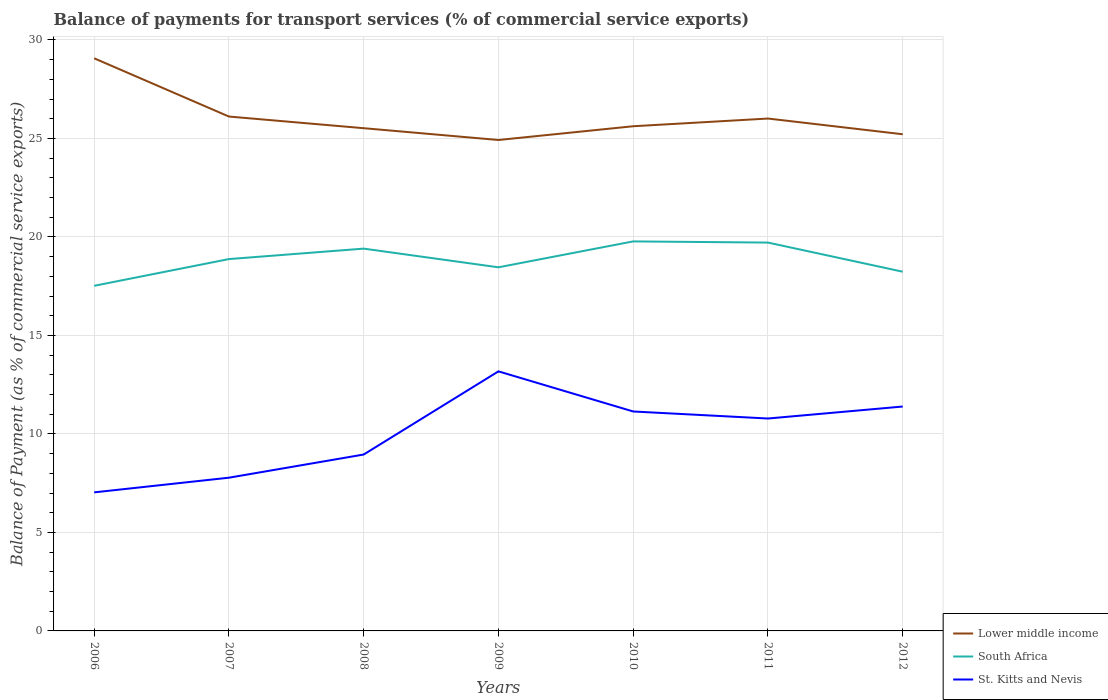Does the line corresponding to St. Kitts and Nevis intersect with the line corresponding to South Africa?
Ensure brevity in your answer.  No. Is the number of lines equal to the number of legend labels?
Ensure brevity in your answer.  Yes. Across all years, what is the maximum balance of payments for transport services in South Africa?
Offer a terse response. 17.52. What is the total balance of payments for transport services in Lower middle income in the graph?
Your answer should be compact. 4.15. What is the difference between the highest and the second highest balance of payments for transport services in South Africa?
Your answer should be compact. 2.25. How many years are there in the graph?
Your answer should be very brief. 7. Where does the legend appear in the graph?
Keep it short and to the point. Bottom right. How are the legend labels stacked?
Keep it short and to the point. Vertical. What is the title of the graph?
Give a very brief answer. Balance of payments for transport services (% of commercial service exports). What is the label or title of the X-axis?
Provide a short and direct response. Years. What is the label or title of the Y-axis?
Ensure brevity in your answer.  Balance of Payment (as % of commercial service exports). What is the Balance of Payment (as % of commercial service exports) in Lower middle income in 2006?
Keep it short and to the point. 29.07. What is the Balance of Payment (as % of commercial service exports) of South Africa in 2006?
Your answer should be very brief. 17.52. What is the Balance of Payment (as % of commercial service exports) in St. Kitts and Nevis in 2006?
Provide a short and direct response. 7.03. What is the Balance of Payment (as % of commercial service exports) of Lower middle income in 2007?
Ensure brevity in your answer.  26.11. What is the Balance of Payment (as % of commercial service exports) in South Africa in 2007?
Your answer should be compact. 18.88. What is the Balance of Payment (as % of commercial service exports) of St. Kitts and Nevis in 2007?
Your answer should be very brief. 7.78. What is the Balance of Payment (as % of commercial service exports) of Lower middle income in 2008?
Offer a very short reply. 25.52. What is the Balance of Payment (as % of commercial service exports) in South Africa in 2008?
Offer a terse response. 19.41. What is the Balance of Payment (as % of commercial service exports) of St. Kitts and Nevis in 2008?
Provide a short and direct response. 8.95. What is the Balance of Payment (as % of commercial service exports) of Lower middle income in 2009?
Provide a short and direct response. 24.92. What is the Balance of Payment (as % of commercial service exports) in South Africa in 2009?
Your answer should be compact. 18.46. What is the Balance of Payment (as % of commercial service exports) of St. Kitts and Nevis in 2009?
Ensure brevity in your answer.  13.18. What is the Balance of Payment (as % of commercial service exports) in Lower middle income in 2010?
Offer a very short reply. 25.62. What is the Balance of Payment (as % of commercial service exports) in South Africa in 2010?
Ensure brevity in your answer.  19.77. What is the Balance of Payment (as % of commercial service exports) in St. Kitts and Nevis in 2010?
Your answer should be compact. 11.14. What is the Balance of Payment (as % of commercial service exports) in Lower middle income in 2011?
Your response must be concise. 26.01. What is the Balance of Payment (as % of commercial service exports) in South Africa in 2011?
Keep it short and to the point. 19.71. What is the Balance of Payment (as % of commercial service exports) of St. Kitts and Nevis in 2011?
Offer a terse response. 10.78. What is the Balance of Payment (as % of commercial service exports) of Lower middle income in 2012?
Ensure brevity in your answer.  25.21. What is the Balance of Payment (as % of commercial service exports) of South Africa in 2012?
Give a very brief answer. 18.23. What is the Balance of Payment (as % of commercial service exports) in St. Kitts and Nevis in 2012?
Offer a very short reply. 11.39. Across all years, what is the maximum Balance of Payment (as % of commercial service exports) in Lower middle income?
Make the answer very short. 29.07. Across all years, what is the maximum Balance of Payment (as % of commercial service exports) in South Africa?
Provide a succinct answer. 19.77. Across all years, what is the maximum Balance of Payment (as % of commercial service exports) of St. Kitts and Nevis?
Give a very brief answer. 13.18. Across all years, what is the minimum Balance of Payment (as % of commercial service exports) in Lower middle income?
Offer a terse response. 24.92. Across all years, what is the minimum Balance of Payment (as % of commercial service exports) of South Africa?
Give a very brief answer. 17.52. Across all years, what is the minimum Balance of Payment (as % of commercial service exports) in St. Kitts and Nevis?
Provide a succinct answer. 7.03. What is the total Balance of Payment (as % of commercial service exports) of Lower middle income in the graph?
Provide a short and direct response. 182.46. What is the total Balance of Payment (as % of commercial service exports) of South Africa in the graph?
Your answer should be very brief. 131.98. What is the total Balance of Payment (as % of commercial service exports) in St. Kitts and Nevis in the graph?
Give a very brief answer. 70.26. What is the difference between the Balance of Payment (as % of commercial service exports) of Lower middle income in 2006 and that in 2007?
Your answer should be very brief. 2.96. What is the difference between the Balance of Payment (as % of commercial service exports) in South Africa in 2006 and that in 2007?
Your response must be concise. -1.36. What is the difference between the Balance of Payment (as % of commercial service exports) in St. Kitts and Nevis in 2006 and that in 2007?
Your response must be concise. -0.74. What is the difference between the Balance of Payment (as % of commercial service exports) of Lower middle income in 2006 and that in 2008?
Offer a very short reply. 3.55. What is the difference between the Balance of Payment (as % of commercial service exports) in South Africa in 2006 and that in 2008?
Offer a very short reply. -1.89. What is the difference between the Balance of Payment (as % of commercial service exports) in St. Kitts and Nevis in 2006 and that in 2008?
Your response must be concise. -1.92. What is the difference between the Balance of Payment (as % of commercial service exports) in Lower middle income in 2006 and that in 2009?
Your answer should be very brief. 4.15. What is the difference between the Balance of Payment (as % of commercial service exports) in South Africa in 2006 and that in 2009?
Your response must be concise. -0.94. What is the difference between the Balance of Payment (as % of commercial service exports) in St. Kitts and Nevis in 2006 and that in 2009?
Your answer should be compact. -6.14. What is the difference between the Balance of Payment (as % of commercial service exports) of Lower middle income in 2006 and that in 2010?
Keep it short and to the point. 3.45. What is the difference between the Balance of Payment (as % of commercial service exports) of South Africa in 2006 and that in 2010?
Your answer should be compact. -2.25. What is the difference between the Balance of Payment (as % of commercial service exports) of St. Kitts and Nevis in 2006 and that in 2010?
Offer a very short reply. -4.11. What is the difference between the Balance of Payment (as % of commercial service exports) of Lower middle income in 2006 and that in 2011?
Your answer should be compact. 3.06. What is the difference between the Balance of Payment (as % of commercial service exports) in South Africa in 2006 and that in 2011?
Your response must be concise. -2.19. What is the difference between the Balance of Payment (as % of commercial service exports) in St. Kitts and Nevis in 2006 and that in 2011?
Offer a terse response. -3.75. What is the difference between the Balance of Payment (as % of commercial service exports) of Lower middle income in 2006 and that in 2012?
Provide a succinct answer. 3.86. What is the difference between the Balance of Payment (as % of commercial service exports) of South Africa in 2006 and that in 2012?
Give a very brief answer. -0.72. What is the difference between the Balance of Payment (as % of commercial service exports) of St. Kitts and Nevis in 2006 and that in 2012?
Offer a very short reply. -4.36. What is the difference between the Balance of Payment (as % of commercial service exports) of Lower middle income in 2007 and that in 2008?
Offer a very short reply. 0.59. What is the difference between the Balance of Payment (as % of commercial service exports) in South Africa in 2007 and that in 2008?
Your answer should be very brief. -0.53. What is the difference between the Balance of Payment (as % of commercial service exports) of St. Kitts and Nevis in 2007 and that in 2008?
Ensure brevity in your answer.  -1.18. What is the difference between the Balance of Payment (as % of commercial service exports) of Lower middle income in 2007 and that in 2009?
Give a very brief answer. 1.19. What is the difference between the Balance of Payment (as % of commercial service exports) in South Africa in 2007 and that in 2009?
Provide a short and direct response. 0.42. What is the difference between the Balance of Payment (as % of commercial service exports) in St. Kitts and Nevis in 2007 and that in 2009?
Keep it short and to the point. -5.4. What is the difference between the Balance of Payment (as % of commercial service exports) in Lower middle income in 2007 and that in 2010?
Provide a short and direct response. 0.49. What is the difference between the Balance of Payment (as % of commercial service exports) of South Africa in 2007 and that in 2010?
Your response must be concise. -0.9. What is the difference between the Balance of Payment (as % of commercial service exports) of St. Kitts and Nevis in 2007 and that in 2010?
Make the answer very short. -3.36. What is the difference between the Balance of Payment (as % of commercial service exports) in Lower middle income in 2007 and that in 2011?
Keep it short and to the point. 0.1. What is the difference between the Balance of Payment (as % of commercial service exports) in South Africa in 2007 and that in 2011?
Give a very brief answer. -0.84. What is the difference between the Balance of Payment (as % of commercial service exports) in St. Kitts and Nevis in 2007 and that in 2011?
Keep it short and to the point. -3. What is the difference between the Balance of Payment (as % of commercial service exports) of Lower middle income in 2007 and that in 2012?
Offer a very short reply. 0.9. What is the difference between the Balance of Payment (as % of commercial service exports) of South Africa in 2007 and that in 2012?
Make the answer very short. 0.64. What is the difference between the Balance of Payment (as % of commercial service exports) in St. Kitts and Nevis in 2007 and that in 2012?
Keep it short and to the point. -3.61. What is the difference between the Balance of Payment (as % of commercial service exports) of Lower middle income in 2008 and that in 2009?
Provide a short and direct response. 0.6. What is the difference between the Balance of Payment (as % of commercial service exports) of South Africa in 2008 and that in 2009?
Provide a short and direct response. 0.95. What is the difference between the Balance of Payment (as % of commercial service exports) of St. Kitts and Nevis in 2008 and that in 2009?
Provide a succinct answer. -4.22. What is the difference between the Balance of Payment (as % of commercial service exports) in Lower middle income in 2008 and that in 2010?
Offer a terse response. -0.1. What is the difference between the Balance of Payment (as % of commercial service exports) in South Africa in 2008 and that in 2010?
Provide a succinct answer. -0.37. What is the difference between the Balance of Payment (as % of commercial service exports) in St. Kitts and Nevis in 2008 and that in 2010?
Offer a terse response. -2.19. What is the difference between the Balance of Payment (as % of commercial service exports) in Lower middle income in 2008 and that in 2011?
Offer a terse response. -0.49. What is the difference between the Balance of Payment (as % of commercial service exports) of South Africa in 2008 and that in 2011?
Offer a terse response. -0.31. What is the difference between the Balance of Payment (as % of commercial service exports) of St. Kitts and Nevis in 2008 and that in 2011?
Provide a short and direct response. -1.83. What is the difference between the Balance of Payment (as % of commercial service exports) in Lower middle income in 2008 and that in 2012?
Give a very brief answer. 0.31. What is the difference between the Balance of Payment (as % of commercial service exports) in South Africa in 2008 and that in 2012?
Your response must be concise. 1.17. What is the difference between the Balance of Payment (as % of commercial service exports) in St. Kitts and Nevis in 2008 and that in 2012?
Provide a succinct answer. -2.44. What is the difference between the Balance of Payment (as % of commercial service exports) in Lower middle income in 2009 and that in 2010?
Provide a succinct answer. -0.7. What is the difference between the Balance of Payment (as % of commercial service exports) in South Africa in 2009 and that in 2010?
Provide a short and direct response. -1.31. What is the difference between the Balance of Payment (as % of commercial service exports) in St. Kitts and Nevis in 2009 and that in 2010?
Ensure brevity in your answer.  2.04. What is the difference between the Balance of Payment (as % of commercial service exports) in Lower middle income in 2009 and that in 2011?
Provide a succinct answer. -1.09. What is the difference between the Balance of Payment (as % of commercial service exports) in South Africa in 2009 and that in 2011?
Make the answer very short. -1.25. What is the difference between the Balance of Payment (as % of commercial service exports) of St. Kitts and Nevis in 2009 and that in 2011?
Keep it short and to the point. 2.39. What is the difference between the Balance of Payment (as % of commercial service exports) in Lower middle income in 2009 and that in 2012?
Make the answer very short. -0.29. What is the difference between the Balance of Payment (as % of commercial service exports) of South Africa in 2009 and that in 2012?
Your answer should be very brief. 0.22. What is the difference between the Balance of Payment (as % of commercial service exports) in St. Kitts and Nevis in 2009 and that in 2012?
Your answer should be compact. 1.79. What is the difference between the Balance of Payment (as % of commercial service exports) of Lower middle income in 2010 and that in 2011?
Give a very brief answer. -0.39. What is the difference between the Balance of Payment (as % of commercial service exports) of South Africa in 2010 and that in 2011?
Keep it short and to the point. 0.06. What is the difference between the Balance of Payment (as % of commercial service exports) of St. Kitts and Nevis in 2010 and that in 2011?
Provide a succinct answer. 0.36. What is the difference between the Balance of Payment (as % of commercial service exports) of Lower middle income in 2010 and that in 2012?
Offer a terse response. 0.41. What is the difference between the Balance of Payment (as % of commercial service exports) in South Africa in 2010 and that in 2012?
Provide a succinct answer. 1.54. What is the difference between the Balance of Payment (as % of commercial service exports) of St. Kitts and Nevis in 2010 and that in 2012?
Give a very brief answer. -0.25. What is the difference between the Balance of Payment (as % of commercial service exports) of Lower middle income in 2011 and that in 2012?
Offer a very short reply. 0.8. What is the difference between the Balance of Payment (as % of commercial service exports) in South Africa in 2011 and that in 2012?
Keep it short and to the point. 1.48. What is the difference between the Balance of Payment (as % of commercial service exports) of St. Kitts and Nevis in 2011 and that in 2012?
Make the answer very short. -0.61. What is the difference between the Balance of Payment (as % of commercial service exports) in Lower middle income in 2006 and the Balance of Payment (as % of commercial service exports) in South Africa in 2007?
Keep it short and to the point. 10.19. What is the difference between the Balance of Payment (as % of commercial service exports) in Lower middle income in 2006 and the Balance of Payment (as % of commercial service exports) in St. Kitts and Nevis in 2007?
Offer a very short reply. 21.29. What is the difference between the Balance of Payment (as % of commercial service exports) in South Africa in 2006 and the Balance of Payment (as % of commercial service exports) in St. Kitts and Nevis in 2007?
Your answer should be very brief. 9.74. What is the difference between the Balance of Payment (as % of commercial service exports) of Lower middle income in 2006 and the Balance of Payment (as % of commercial service exports) of South Africa in 2008?
Your answer should be compact. 9.66. What is the difference between the Balance of Payment (as % of commercial service exports) in Lower middle income in 2006 and the Balance of Payment (as % of commercial service exports) in St. Kitts and Nevis in 2008?
Ensure brevity in your answer.  20.11. What is the difference between the Balance of Payment (as % of commercial service exports) in South Africa in 2006 and the Balance of Payment (as % of commercial service exports) in St. Kitts and Nevis in 2008?
Give a very brief answer. 8.56. What is the difference between the Balance of Payment (as % of commercial service exports) in Lower middle income in 2006 and the Balance of Payment (as % of commercial service exports) in South Africa in 2009?
Make the answer very short. 10.61. What is the difference between the Balance of Payment (as % of commercial service exports) of Lower middle income in 2006 and the Balance of Payment (as % of commercial service exports) of St. Kitts and Nevis in 2009?
Give a very brief answer. 15.89. What is the difference between the Balance of Payment (as % of commercial service exports) in South Africa in 2006 and the Balance of Payment (as % of commercial service exports) in St. Kitts and Nevis in 2009?
Offer a very short reply. 4.34. What is the difference between the Balance of Payment (as % of commercial service exports) of Lower middle income in 2006 and the Balance of Payment (as % of commercial service exports) of South Africa in 2010?
Your answer should be very brief. 9.3. What is the difference between the Balance of Payment (as % of commercial service exports) of Lower middle income in 2006 and the Balance of Payment (as % of commercial service exports) of St. Kitts and Nevis in 2010?
Your response must be concise. 17.93. What is the difference between the Balance of Payment (as % of commercial service exports) in South Africa in 2006 and the Balance of Payment (as % of commercial service exports) in St. Kitts and Nevis in 2010?
Offer a terse response. 6.38. What is the difference between the Balance of Payment (as % of commercial service exports) in Lower middle income in 2006 and the Balance of Payment (as % of commercial service exports) in South Africa in 2011?
Provide a short and direct response. 9.36. What is the difference between the Balance of Payment (as % of commercial service exports) of Lower middle income in 2006 and the Balance of Payment (as % of commercial service exports) of St. Kitts and Nevis in 2011?
Make the answer very short. 18.29. What is the difference between the Balance of Payment (as % of commercial service exports) in South Africa in 2006 and the Balance of Payment (as % of commercial service exports) in St. Kitts and Nevis in 2011?
Keep it short and to the point. 6.74. What is the difference between the Balance of Payment (as % of commercial service exports) in Lower middle income in 2006 and the Balance of Payment (as % of commercial service exports) in South Africa in 2012?
Keep it short and to the point. 10.83. What is the difference between the Balance of Payment (as % of commercial service exports) of Lower middle income in 2006 and the Balance of Payment (as % of commercial service exports) of St. Kitts and Nevis in 2012?
Your answer should be very brief. 17.68. What is the difference between the Balance of Payment (as % of commercial service exports) in South Africa in 2006 and the Balance of Payment (as % of commercial service exports) in St. Kitts and Nevis in 2012?
Your answer should be very brief. 6.13. What is the difference between the Balance of Payment (as % of commercial service exports) of Lower middle income in 2007 and the Balance of Payment (as % of commercial service exports) of South Africa in 2008?
Provide a succinct answer. 6.71. What is the difference between the Balance of Payment (as % of commercial service exports) in Lower middle income in 2007 and the Balance of Payment (as % of commercial service exports) in St. Kitts and Nevis in 2008?
Your answer should be compact. 17.16. What is the difference between the Balance of Payment (as % of commercial service exports) of South Africa in 2007 and the Balance of Payment (as % of commercial service exports) of St. Kitts and Nevis in 2008?
Your answer should be compact. 9.92. What is the difference between the Balance of Payment (as % of commercial service exports) of Lower middle income in 2007 and the Balance of Payment (as % of commercial service exports) of South Africa in 2009?
Your response must be concise. 7.65. What is the difference between the Balance of Payment (as % of commercial service exports) in Lower middle income in 2007 and the Balance of Payment (as % of commercial service exports) in St. Kitts and Nevis in 2009?
Ensure brevity in your answer.  12.94. What is the difference between the Balance of Payment (as % of commercial service exports) of South Africa in 2007 and the Balance of Payment (as % of commercial service exports) of St. Kitts and Nevis in 2009?
Your response must be concise. 5.7. What is the difference between the Balance of Payment (as % of commercial service exports) in Lower middle income in 2007 and the Balance of Payment (as % of commercial service exports) in South Africa in 2010?
Provide a short and direct response. 6.34. What is the difference between the Balance of Payment (as % of commercial service exports) of Lower middle income in 2007 and the Balance of Payment (as % of commercial service exports) of St. Kitts and Nevis in 2010?
Your answer should be compact. 14.97. What is the difference between the Balance of Payment (as % of commercial service exports) of South Africa in 2007 and the Balance of Payment (as % of commercial service exports) of St. Kitts and Nevis in 2010?
Offer a terse response. 7.74. What is the difference between the Balance of Payment (as % of commercial service exports) of Lower middle income in 2007 and the Balance of Payment (as % of commercial service exports) of South Africa in 2011?
Give a very brief answer. 6.4. What is the difference between the Balance of Payment (as % of commercial service exports) in Lower middle income in 2007 and the Balance of Payment (as % of commercial service exports) in St. Kitts and Nevis in 2011?
Keep it short and to the point. 15.33. What is the difference between the Balance of Payment (as % of commercial service exports) of South Africa in 2007 and the Balance of Payment (as % of commercial service exports) of St. Kitts and Nevis in 2011?
Offer a terse response. 8.09. What is the difference between the Balance of Payment (as % of commercial service exports) in Lower middle income in 2007 and the Balance of Payment (as % of commercial service exports) in South Africa in 2012?
Give a very brief answer. 7.88. What is the difference between the Balance of Payment (as % of commercial service exports) of Lower middle income in 2007 and the Balance of Payment (as % of commercial service exports) of St. Kitts and Nevis in 2012?
Offer a terse response. 14.72. What is the difference between the Balance of Payment (as % of commercial service exports) in South Africa in 2007 and the Balance of Payment (as % of commercial service exports) in St. Kitts and Nevis in 2012?
Provide a short and direct response. 7.49. What is the difference between the Balance of Payment (as % of commercial service exports) of Lower middle income in 2008 and the Balance of Payment (as % of commercial service exports) of South Africa in 2009?
Offer a very short reply. 7.06. What is the difference between the Balance of Payment (as % of commercial service exports) in Lower middle income in 2008 and the Balance of Payment (as % of commercial service exports) in St. Kitts and Nevis in 2009?
Give a very brief answer. 12.34. What is the difference between the Balance of Payment (as % of commercial service exports) in South Africa in 2008 and the Balance of Payment (as % of commercial service exports) in St. Kitts and Nevis in 2009?
Your answer should be very brief. 6.23. What is the difference between the Balance of Payment (as % of commercial service exports) in Lower middle income in 2008 and the Balance of Payment (as % of commercial service exports) in South Africa in 2010?
Provide a succinct answer. 5.75. What is the difference between the Balance of Payment (as % of commercial service exports) of Lower middle income in 2008 and the Balance of Payment (as % of commercial service exports) of St. Kitts and Nevis in 2010?
Make the answer very short. 14.38. What is the difference between the Balance of Payment (as % of commercial service exports) of South Africa in 2008 and the Balance of Payment (as % of commercial service exports) of St. Kitts and Nevis in 2010?
Provide a succinct answer. 8.27. What is the difference between the Balance of Payment (as % of commercial service exports) of Lower middle income in 2008 and the Balance of Payment (as % of commercial service exports) of South Africa in 2011?
Provide a succinct answer. 5.81. What is the difference between the Balance of Payment (as % of commercial service exports) in Lower middle income in 2008 and the Balance of Payment (as % of commercial service exports) in St. Kitts and Nevis in 2011?
Your answer should be very brief. 14.74. What is the difference between the Balance of Payment (as % of commercial service exports) of South Africa in 2008 and the Balance of Payment (as % of commercial service exports) of St. Kitts and Nevis in 2011?
Your response must be concise. 8.62. What is the difference between the Balance of Payment (as % of commercial service exports) of Lower middle income in 2008 and the Balance of Payment (as % of commercial service exports) of South Africa in 2012?
Ensure brevity in your answer.  7.29. What is the difference between the Balance of Payment (as % of commercial service exports) of Lower middle income in 2008 and the Balance of Payment (as % of commercial service exports) of St. Kitts and Nevis in 2012?
Keep it short and to the point. 14.13. What is the difference between the Balance of Payment (as % of commercial service exports) in South Africa in 2008 and the Balance of Payment (as % of commercial service exports) in St. Kitts and Nevis in 2012?
Provide a short and direct response. 8.02. What is the difference between the Balance of Payment (as % of commercial service exports) in Lower middle income in 2009 and the Balance of Payment (as % of commercial service exports) in South Africa in 2010?
Provide a succinct answer. 5.15. What is the difference between the Balance of Payment (as % of commercial service exports) of Lower middle income in 2009 and the Balance of Payment (as % of commercial service exports) of St. Kitts and Nevis in 2010?
Keep it short and to the point. 13.78. What is the difference between the Balance of Payment (as % of commercial service exports) in South Africa in 2009 and the Balance of Payment (as % of commercial service exports) in St. Kitts and Nevis in 2010?
Make the answer very short. 7.32. What is the difference between the Balance of Payment (as % of commercial service exports) in Lower middle income in 2009 and the Balance of Payment (as % of commercial service exports) in South Africa in 2011?
Your answer should be compact. 5.21. What is the difference between the Balance of Payment (as % of commercial service exports) of Lower middle income in 2009 and the Balance of Payment (as % of commercial service exports) of St. Kitts and Nevis in 2011?
Provide a succinct answer. 14.14. What is the difference between the Balance of Payment (as % of commercial service exports) in South Africa in 2009 and the Balance of Payment (as % of commercial service exports) in St. Kitts and Nevis in 2011?
Your response must be concise. 7.68. What is the difference between the Balance of Payment (as % of commercial service exports) in Lower middle income in 2009 and the Balance of Payment (as % of commercial service exports) in South Africa in 2012?
Your answer should be compact. 6.69. What is the difference between the Balance of Payment (as % of commercial service exports) of Lower middle income in 2009 and the Balance of Payment (as % of commercial service exports) of St. Kitts and Nevis in 2012?
Provide a succinct answer. 13.53. What is the difference between the Balance of Payment (as % of commercial service exports) in South Africa in 2009 and the Balance of Payment (as % of commercial service exports) in St. Kitts and Nevis in 2012?
Offer a very short reply. 7.07. What is the difference between the Balance of Payment (as % of commercial service exports) in Lower middle income in 2010 and the Balance of Payment (as % of commercial service exports) in South Africa in 2011?
Your response must be concise. 5.91. What is the difference between the Balance of Payment (as % of commercial service exports) in Lower middle income in 2010 and the Balance of Payment (as % of commercial service exports) in St. Kitts and Nevis in 2011?
Provide a short and direct response. 14.84. What is the difference between the Balance of Payment (as % of commercial service exports) in South Africa in 2010 and the Balance of Payment (as % of commercial service exports) in St. Kitts and Nevis in 2011?
Make the answer very short. 8.99. What is the difference between the Balance of Payment (as % of commercial service exports) in Lower middle income in 2010 and the Balance of Payment (as % of commercial service exports) in South Africa in 2012?
Your answer should be very brief. 7.38. What is the difference between the Balance of Payment (as % of commercial service exports) in Lower middle income in 2010 and the Balance of Payment (as % of commercial service exports) in St. Kitts and Nevis in 2012?
Make the answer very short. 14.23. What is the difference between the Balance of Payment (as % of commercial service exports) of South Africa in 2010 and the Balance of Payment (as % of commercial service exports) of St. Kitts and Nevis in 2012?
Make the answer very short. 8.38. What is the difference between the Balance of Payment (as % of commercial service exports) of Lower middle income in 2011 and the Balance of Payment (as % of commercial service exports) of South Africa in 2012?
Make the answer very short. 7.78. What is the difference between the Balance of Payment (as % of commercial service exports) of Lower middle income in 2011 and the Balance of Payment (as % of commercial service exports) of St. Kitts and Nevis in 2012?
Your answer should be compact. 14.62. What is the difference between the Balance of Payment (as % of commercial service exports) of South Africa in 2011 and the Balance of Payment (as % of commercial service exports) of St. Kitts and Nevis in 2012?
Your response must be concise. 8.32. What is the average Balance of Payment (as % of commercial service exports) in Lower middle income per year?
Your response must be concise. 26.07. What is the average Balance of Payment (as % of commercial service exports) of South Africa per year?
Provide a short and direct response. 18.85. What is the average Balance of Payment (as % of commercial service exports) in St. Kitts and Nevis per year?
Your answer should be compact. 10.04. In the year 2006, what is the difference between the Balance of Payment (as % of commercial service exports) in Lower middle income and Balance of Payment (as % of commercial service exports) in South Africa?
Your answer should be compact. 11.55. In the year 2006, what is the difference between the Balance of Payment (as % of commercial service exports) of Lower middle income and Balance of Payment (as % of commercial service exports) of St. Kitts and Nevis?
Ensure brevity in your answer.  22.04. In the year 2006, what is the difference between the Balance of Payment (as % of commercial service exports) of South Africa and Balance of Payment (as % of commercial service exports) of St. Kitts and Nevis?
Ensure brevity in your answer.  10.49. In the year 2007, what is the difference between the Balance of Payment (as % of commercial service exports) in Lower middle income and Balance of Payment (as % of commercial service exports) in South Africa?
Keep it short and to the point. 7.24. In the year 2007, what is the difference between the Balance of Payment (as % of commercial service exports) of Lower middle income and Balance of Payment (as % of commercial service exports) of St. Kitts and Nevis?
Give a very brief answer. 18.33. In the year 2007, what is the difference between the Balance of Payment (as % of commercial service exports) of South Africa and Balance of Payment (as % of commercial service exports) of St. Kitts and Nevis?
Ensure brevity in your answer.  11.1. In the year 2008, what is the difference between the Balance of Payment (as % of commercial service exports) in Lower middle income and Balance of Payment (as % of commercial service exports) in South Africa?
Give a very brief answer. 6.11. In the year 2008, what is the difference between the Balance of Payment (as % of commercial service exports) of Lower middle income and Balance of Payment (as % of commercial service exports) of St. Kitts and Nevis?
Make the answer very short. 16.57. In the year 2008, what is the difference between the Balance of Payment (as % of commercial service exports) of South Africa and Balance of Payment (as % of commercial service exports) of St. Kitts and Nevis?
Your answer should be compact. 10.45. In the year 2009, what is the difference between the Balance of Payment (as % of commercial service exports) in Lower middle income and Balance of Payment (as % of commercial service exports) in South Africa?
Your response must be concise. 6.46. In the year 2009, what is the difference between the Balance of Payment (as % of commercial service exports) in Lower middle income and Balance of Payment (as % of commercial service exports) in St. Kitts and Nevis?
Ensure brevity in your answer.  11.74. In the year 2009, what is the difference between the Balance of Payment (as % of commercial service exports) in South Africa and Balance of Payment (as % of commercial service exports) in St. Kitts and Nevis?
Ensure brevity in your answer.  5.28. In the year 2010, what is the difference between the Balance of Payment (as % of commercial service exports) of Lower middle income and Balance of Payment (as % of commercial service exports) of South Africa?
Provide a succinct answer. 5.85. In the year 2010, what is the difference between the Balance of Payment (as % of commercial service exports) of Lower middle income and Balance of Payment (as % of commercial service exports) of St. Kitts and Nevis?
Offer a very short reply. 14.48. In the year 2010, what is the difference between the Balance of Payment (as % of commercial service exports) of South Africa and Balance of Payment (as % of commercial service exports) of St. Kitts and Nevis?
Your answer should be compact. 8.63. In the year 2011, what is the difference between the Balance of Payment (as % of commercial service exports) of Lower middle income and Balance of Payment (as % of commercial service exports) of South Africa?
Provide a succinct answer. 6.3. In the year 2011, what is the difference between the Balance of Payment (as % of commercial service exports) in Lower middle income and Balance of Payment (as % of commercial service exports) in St. Kitts and Nevis?
Ensure brevity in your answer.  15.23. In the year 2011, what is the difference between the Balance of Payment (as % of commercial service exports) of South Africa and Balance of Payment (as % of commercial service exports) of St. Kitts and Nevis?
Your answer should be compact. 8.93. In the year 2012, what is the difference between the Balance of Payment (as % of commercial service exports) in Lower middle income and Balance of Payment (as % of commercial service exports) in South Africa?
Provide a succinct answer. 6.98. In the year 2012, what is the difference between the Balance of Payment (as % of commercial service exports) in Lower middle income and Balance of Payment (as % of commercial service exports) in St. Kitts and Nevis?
Your answer should be very brief. 13.82. In the year 2012, what is the difference between the Balance of Payment (as % of commercial service exports) in South Africa and Balance of Payment (as % of commercial service exports) in St. Kitts and Nevis?
Your response must be concise. 6.84. What is the ratio of the Balance of Payment (as % of commercial service exports) in Lower middle income in 2006 to that in 2007?
Offer a terse response. 1.11. What is the ratio of the Balance of Payment (as % of commercial service exports) of South Africa in 2006 to that in 2007?
Your answer should be compact. 0.93. What is the ratio of the Balance of Payment (as % of commercial service exports) of St. Kitts and Nevis in 2006 to that in 2007?
Your answer should be very brief. 0.9. What is the ratio of the Balance of Payment (as % of commercial service exports) of Lower middle income in 2006 to that in 2008?
Offer a terse response. 1.14. What is the ratio of the Balance of Payment (as % of commercial service exports) of South Africa in 2006 to that in 2008?
Your response must be concise. 0.9. What is the ratio of the Balance of Payment (as % of commercial service exports) in St. Kitts and Nevis in 2006 to that in 2008?
Keep it short and to the point. 0.79. What is the ratio of the Balance of Payment (as % of commercial service exports) in Lower middle income in 2006 to that in 2009?
Your answer should be compact. 1.17. What is the ratio of the Balance of Payment (as % of commercial service exports) of South Africa in 2006 to that in 2009?
Keep it short and to the point. 0.95. What is the ratio of the Balance of Payment (as % of commercial service exports) of St. Kitts and Nevis in 2006 to that in 2009?
Provide a succinct answer. 0.53. What is the ratio of the Balance of Payment (as % of commercial service exports) of Lower middle income in 2006 to that in 2010?
Offer a terse response. 1.13. What is the ratio of the Balance of Payment (as % of commercial service exports) of South Africa in 2006 to that in 2010?
Your response must be concise. 0.89. What is the ratio of the Balance of Payment (as % of commercial service exports) of St. Kitts and Nevis in 2006 to that in 2010?
Your answer should be very brief. 0.63. What is the ratio of the Balance of Payment (as % of commercial service exports) in Lower middle income in 2006 to that in 2011?
Offer a terse response. 1.12. What is the ratio of the Balance of Payment (as % of commercial service exports) of South Africa in 2006 to that in 2011?
Make the answer very short. 0.89. What is the ratio of the Balance of Payment (as % of commercial service exports) of St. Kitts and Nevis in 2006 to that in 2011?
Your response must be concise. 0.65. What is the ratio of the Balance of Payment (as % of commercial service exports) in Lower middle income in 2006 to that in 2012?
Ensure brevity in your answer.  1.15. What is the ratio of the Balance of Payment (as % of commercial service exports) in South Africa in 2006 to that in 2012?
Your answer should be compact. 0.96. What is the ratio of the Balance of Payment (as % of commercial service exports) of St. Kitts and Nevis in 2006 to that in 2012?
Your answer should be compact. 0.62. What is the ratio of the Balance of Payment (as % of commercial service exports) of Lower middle income in 2007 to that in 2008?
Ensure brevity in your answer.  1.02. What is the ratio of the Balance of Payment (as % of commercial service exports) of South Africa in 2007 to that in 2008?
Make the answer very short. 0.97. What is the ratio of the Balance of Payment (as % of commercial service exports) of St. Kitts and Nevis in 2007 to that in 2008?
Your response must be concise. 0.87. What is the ratio of the Balance of Payment (as % of commercial service exports) of Lower middle income in 2007 to that in 2009?
Keep it short and to the point. 1.05. What is the ratio of the Balance of Payment (as % of commercial service exports) in South Africa in 2007 to that in 2009?
Your response must be concise. 1.02. What is the ratio of the Balance of Payment (as % of commercial service exports) in St. Kitts and Nevis in 2007 to that in 2009?
Provide a succinct answer. 0.59. What is the ratio of the Balance of Payment (as % of commercial service exports) of Lower middle income in 2007 to that in 2010?
Provide a succinct answer. 1.02. What is the ratio of the Balance of Payment (as % of commercial service exports) in South Africa in 2007 to that in 2010?
Offer a very short reply. 0.95. What is the ratio of the Balance of Payment (as % of commercial service exports) of St. Kitts and Nevis in 2007 to that in 2010?
Keep it short and to the point. 0.7. What is the ratio of the Balance of Payment (as % of commercial service exports) of Lower middle income in 2007 to that in 2011?
Make the answer very short. 1. What is the ratio of the Balance of Payment (as % of commercial service exports) in South Africa in 2007 to that in 2011?
Your response must be concise. 0.96. What is the ratio of the Balance of Payment (as % of commercial service exports) of St. Kitts and Nevis in 2007 to that in 2011?
Offer a terse response. 0.72. What is the ratio of the Balance of Payment (as % of commercial service exports) in Lower middle income in 2007 to that in 2012?
Your answer should be compact. 1.04. What is the ratio of the Balance of Payment (as % of commercial service exports) in South Africa in 2007 to that in 2012?
Offer a very short reply. 1.04. What is the ratio of the Balance of Payment (as % of commercial service exports) in St. Kitts and Nevis in 2007 to that in 2012?
Your response must be concise. 0.68. What is the ratio of the Balance of Payment (as % of commercial service exports) in South Africa in 2008 to that in 2009?
Your response must be concise. 1.05. What is the ratio of the Balance of Payment (as % of commercial service exports) in St. Kitts and Nevis in 2008 to that in 2009?
Ensure brevity in your answer.  0.68. What is the ratio of the Balance of Payment (as % of commercial service exports) in Lower middle income in 2008 to that in 2010?
Ensure brevity in your answer.  1. What is the ratio of the Balance of Payment (as % of commercial service exports) of South Africa in 2008 to that in 2010?
Provide a short and direct response. 0.98. What is the ratio of the Balance of Payment (as % of commercial service exports) in St. Kitts and Nevis in 2008 to that in 2010?
Ensure brevity in your answer.  0.8. What is the ratio of the Balance of Payment (as % of commercial service exports) of Lower middle income in 2008 to that in 2011?
Offer a terse response. 0.98. What is the ratio of the Balance of Payment (as % of commercial service exports) of South Africa in 2008 to that in 2011?
Offer a terse response. 0.98. What is the ratio of the Balance of Payment (as % of commercial service exports) of St. Kitts and Nevis in 2008 to that in 2011?
Your response must be concise. 0.83. What is the ratio of the Balance of Payment (as % of commercial service exports) in Lower middle income in 2008 to that in 2012?
Your answer should be compact. 1.01. What is the ratio of the Balance of Payment (as % of commercial service exports) in South Africa in 2008 to that in 2012?
Provide a short and direct response. 1.06. What is the ratio of the Balance of Payment (as % of commercial service exports) of St. Kitts and Nevis in 2008 to that in 2012?
Provide a succinct answer. 0.79. What is the ratio of the Balance of Payment (as % of commercial service exports) in Lower middle income in 2009 to that in 2010?
Give a very brief answer. 0.97. What is the ratio of the Balance of Payment (as % of commercial service exports) in South Africa in 2009 to that in 2010?
Give a very brief answer. 0.93. What is the ratio of the Balance of Payment (as % of commercial service exports) in St. Kitts and Nevis in 2009 to that in 2010?
Make the answer very short. 1.18. What is the ratio of the Balance of Payment (as % of commercial service exports) in Lower middle income in 2009 to that in 2011?
Offer a very short reply. 0.96. What is the ratio of the Balance of Payment (as % of commercial service exports) of South Africa in 2009 to that in 2011?
Give a very brief answer. 0.94. What is the ratio of the Balance of Payment (as % of commercial service exports) in St. Kitts and Nevis in 2009 to that in 2011?
Give a very brief answer. 1.22. What is the ratio of the Balance of Payment (as % of commercial service exports) of South Africa in 2009 to that in 2012?
Offer a very short reply. 1.01. What is the ratio of the Balance of Payment (as % of commercial service exports) in St. Kitts and Nevis in 2009 to that in 2012?
Offer a very short reply. 1.16. What is the ratio of the Balance of Payment (as % of commercial service exports) of Lower middle income in 2010 to that in 2011?
Your answer should be compact. 0.98. What is the ratio of the Balance of Payment (as % of commercial service exports) of South Africa in 2010 to that in 2011?
Your answer should be compact. 1. What is the ratio of the Balance of Payment (as % of commercial service exports) of St. Kitts and Nevis in 2010 to that in 2011?
Give a very brief answer. 1.03. What is the ratio of the Balance of Payment (as % of commercial service exports) in Lower middle income in 2010 to that in 2012?
Give a very brief answer. 1.02. What is the ratio of the Balance of Payment (as % of commercial service exports) in South Africa in 2010 to that in 2012?
Your answer should be compact. 1.08. What is the ratio of the Balance of Payment (as % of commercial service exports) of St. Kitts and Nevis in 2010 to that in 2012?
Provide a short and direct response. 0.98. What is the ratio of the Balance of Payment (as % of commercial service exports) in Lower middle income in 2011 to that in 2012?
Keep it short and to the point. 1.03. What is the ratio of the Balance of Payment (as % of commercial service exports) in South Africa in 2011 to that in 2012?
Provide a succinct answer. 1.08. What is the ratio of the Balance of Payment (as % of commercial service exports) in St. Kitts and Nevis in 2011 to that in 2012?
Your answer should be compact. 0.95. What is the difference between the highest and the second highest Balance of Payment (as % of commercial service exports) of Lower middle income?
Offer a terse response. 2.96. What is the difference between the highest and the second highest Balance of Payment (as % of commercial service exports) in South Africa?
Offer a very short reply. 0.06. What is the difference between the highest and the second highest Balance of Payment (as % of commercial service exports) of St. Kitts and Nevis?
Keep it short and to the point. 1.79. What is the difference between the highest and the lowest Balance of Payment (as % of commercial service exports) in Lower middle income?
Provide a short and direct response. 4.15. What is the difference between the highest and the lowest Balance of Payment (as % of commercial service exports) in South Africa?
Give a very brief answer. 2.25. What is the difference between the highest and the lowest Balance of Payment (as % of commercial service exports) of St. Kitts and Nevis?
Provide a short and direct response. 6.14. 